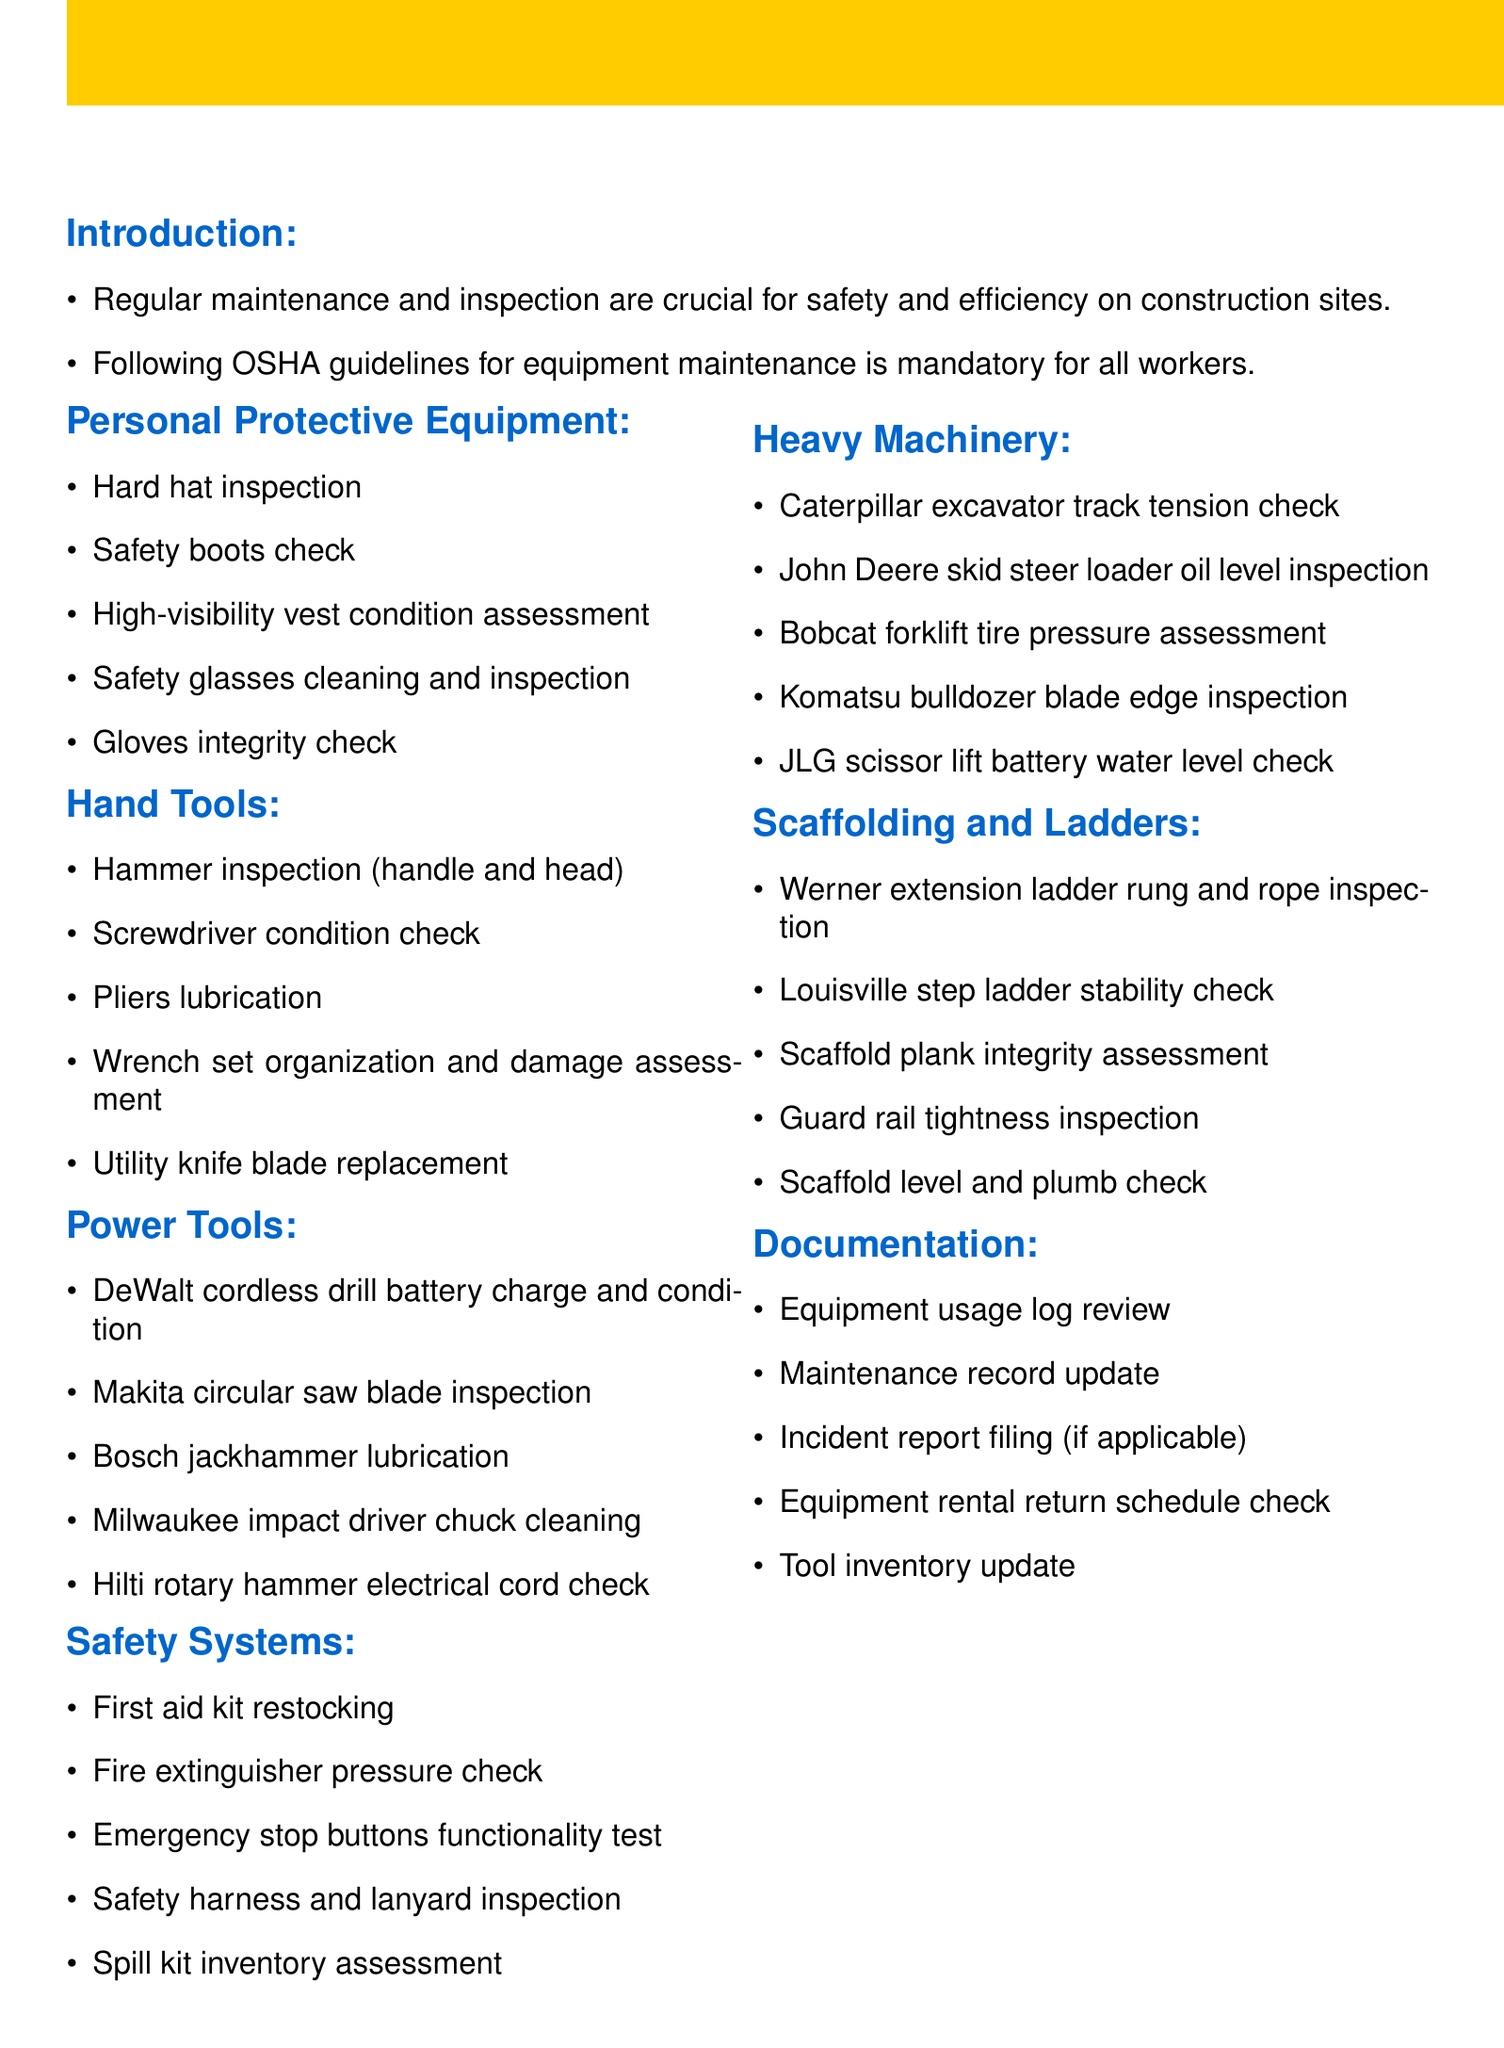What is the agenda title? The agenda title is the main heading that describes the content of the document.
Answer: Weekly Equipment Maintenance and Inspection Checklist Who should follow the OSHA guidelines? OSHA guidelines apply to all workers involved in equipment maintenance on construction sites.
Answer: All workers What is checked during personal protective equipment inspection? Personal protective equipment inspection covers several items related to workers' safety gear.
Answer: Hard hat inspection Which tool requires lubrication? This type of question identifies a specific hand tool that requires maintenance attention regarding lubrication.
Answer: Pliers lubrication What is included in the documentation section? This asks for the items found within the documentation section regarding equipment management.
Answer: Equipment usage log review What type of ladder is inspected for stability? This question looks for a specific type of ladder mentioned in the scaffolding and ladders section.
Answer: Louisville step ladder How many training reminders are listed? The document contains a specific number of training reminders related to worker safety and protocols.
Answer: Five What should be done if equipment issues arise? This question references the procedure suggested in the conclusion section regarding issues with equipment.
Answer: Report to the site supervisor immediately What routine check is performed on fire extinguishers? This question identifies the specific maintenance action required for fire safety equipment.
Answer: Pressure check 